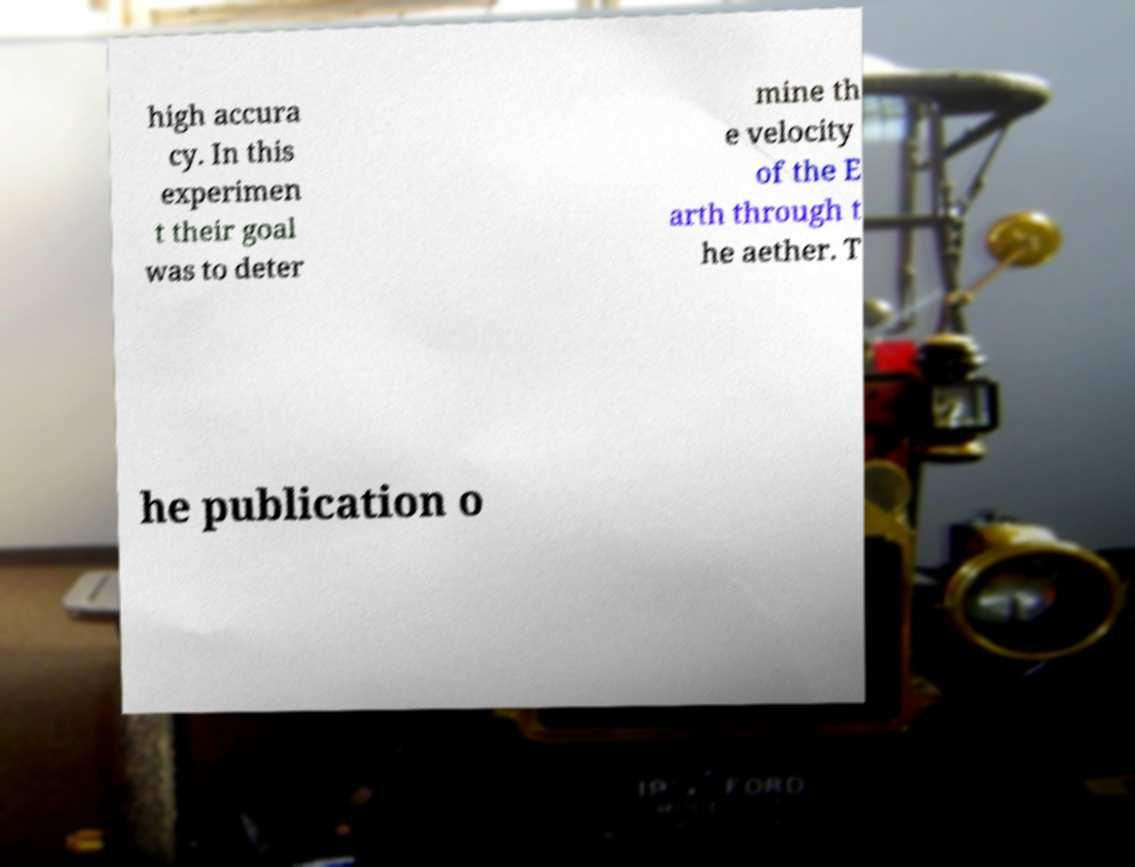Could you assist in decoding the text presented in this image and type it out clearly? high accura cy. In this experimen t their goal was to deter mine th e velocity of the E arth through t he aether. T he publication o 